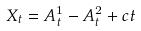Convert formula to latex. <formula><loc_0><loc_0><loc_500><loc_500>X _ { t } = A ^ { 1 } _ { t } - A ^ { 2 } _ { t } + c t</formula> 